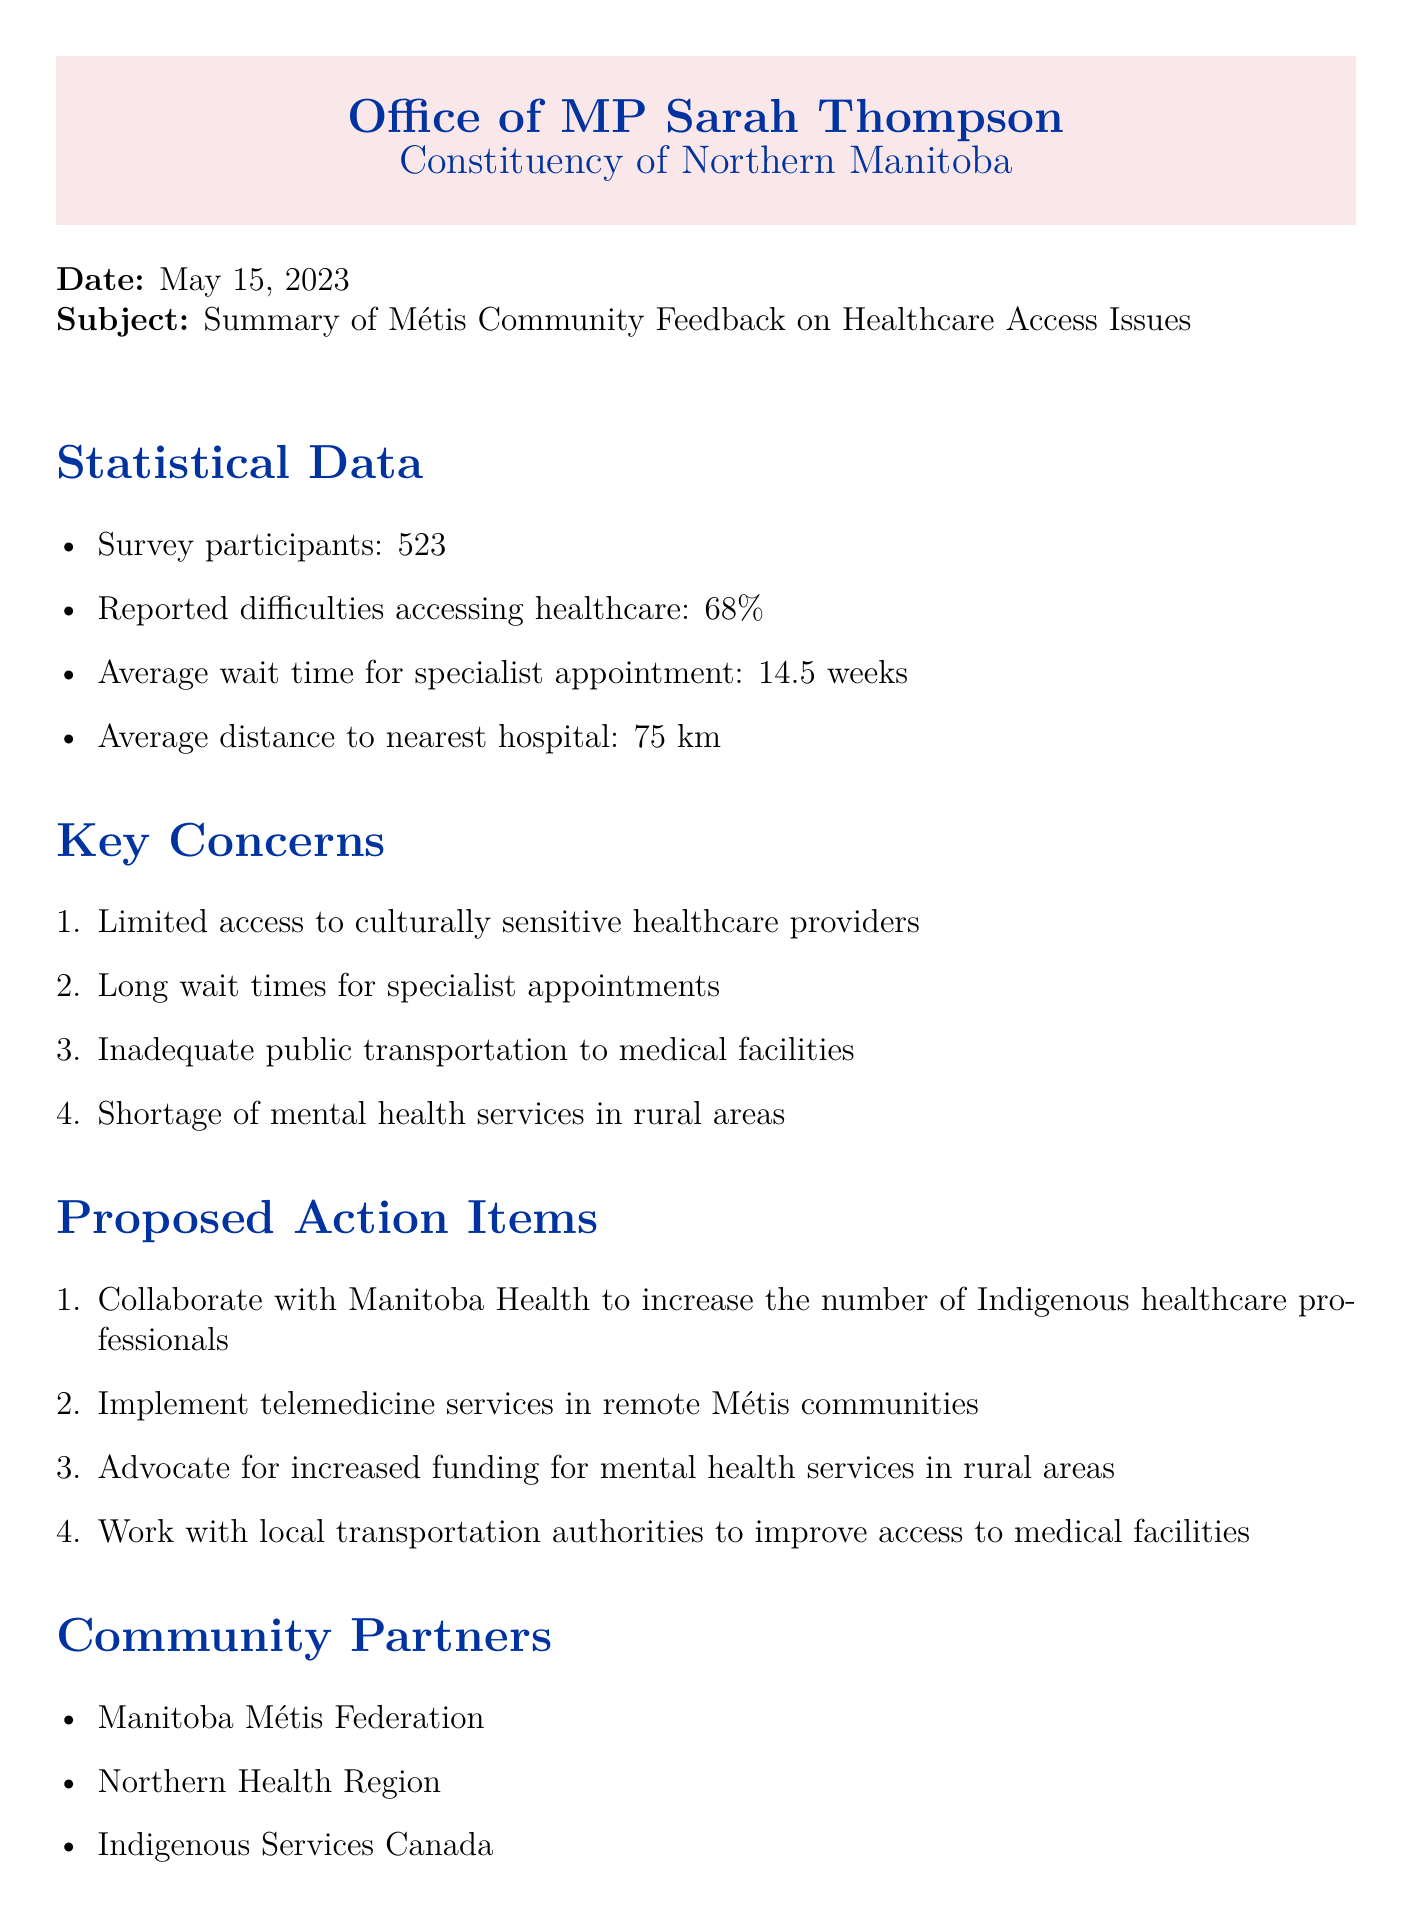What percentage of survey participants reported difficulties accessing healthcare? The document states that 68% of surveyed participants reported difficulties in accessing healthcare.
Answer: 68% What is the average wait time for a specialist appointment? It is mentioned that the average wait time for a specialist appointment is 14.5 weeks.
Answer: 14.5 weeks What is one key concern noted in the community feedback? The document lists limited access to culturally sensitive healthcare providers as one of the key concerns.
Answer: Limited access to culturally sensitive healthcare providers Which three organizations are listed as community partners? The document identifies Manitoba Métis Federation, Northern Health Region, and Indigenous Services Canada as community partners.
Answer: Manitoba Métis Federation, Northern Health Region, Indigenous Services Canada What is one proposed action item to address healthcare access issues? The document suggests collaborating with Manitoba Health to increase the number of Indigenous healthcare professionals as a proposed action item.
Answer: Collaborate with Manitoba Health to increase the number of Indigenous healthcare professionals What is the average distance to the nearest hospital? The document indicates the average distance to the nearest hospital is 75 km.
Answer: 75 km What is the date of the scheduled town hall meeting? The document specifies that the town hall meeting is scheduled for June 1, 2023.
Answer: June 1, 2023 How many survey participants were there? The document mentions that there were 523 survey participants.
Answer: 523 